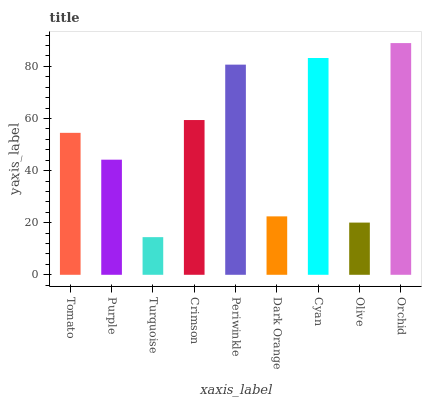Is Turquoise the minimum?
Answer yes or no. Yes. Is Orchid the maximum?
Answer yes or no. Yes. Is Purple the minimum?
Answer yes or no. No. Is Purple the maximum?
Answer yes or no. No. Is Tomato greater than Purple?
Answer yes or no. Yes. Is Purple less than Tomato?
Answer yes or no. Yes. Is Purple greater than Tomato?
Answer yes or no. No. Is Tomato less than Purple?
Answer yes or no. No. Is Tomato the high median?
Answer yes or no. Yes. Is Tomato the low median?
Answer yes or no. Yes. Is Turquoise the high median?
Answer yes or no. No. Is Purple the low median?
Answer yes or no. No. 